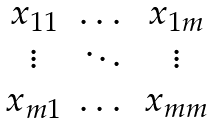Convert formula to latex. <formula><loc_0><loc_0><loc_500><loc_500>\begin{matrix} x _ { 1 1 } & \dots & x _ { 1 m } \\ \vdots & \ddots & \vdots \\ x _ { m 1 } & \dots & x _ { m m } \end{matrix}</formula> 